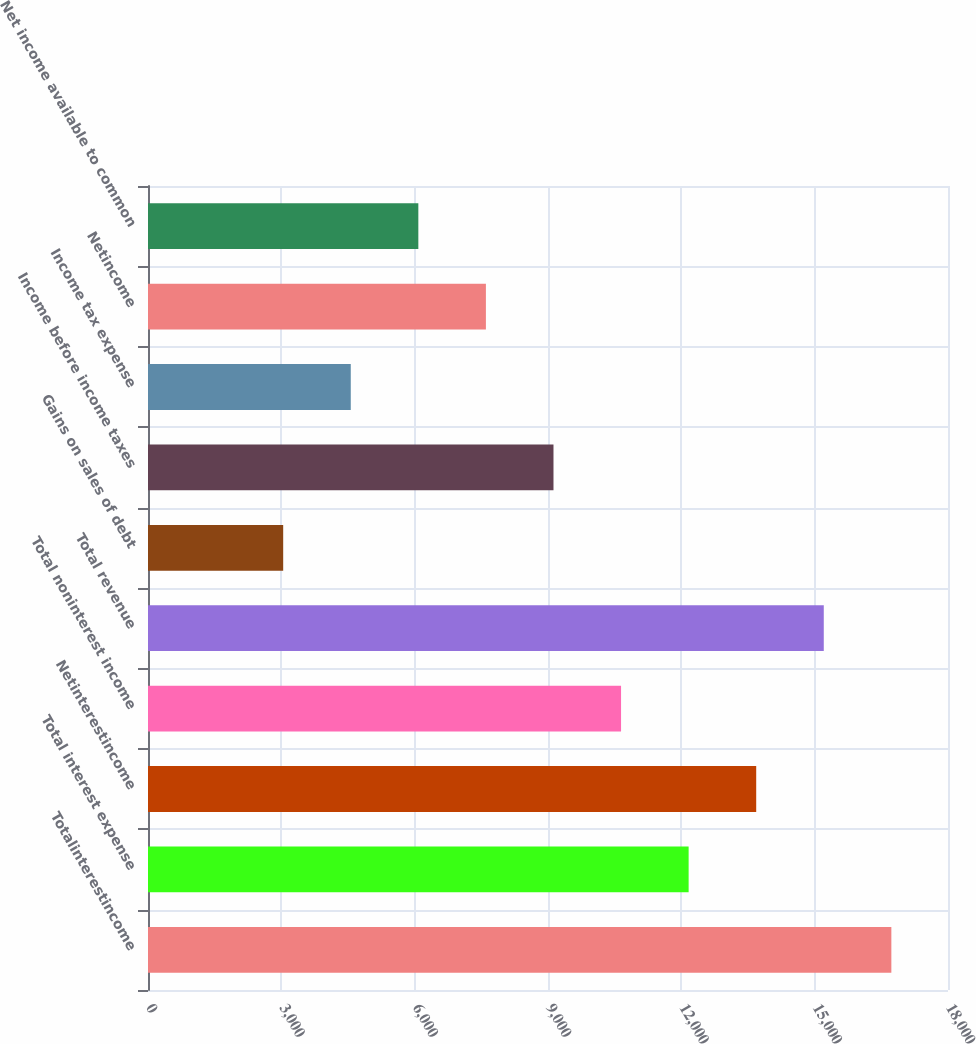Convert chart to OTSL. <chart><loc_0><loc_0><loc_500><loc_500><bar_chart><fcel>Totalinterestincome<fcel>Total interest expense<fcel>Netinterestincome<fcel>Total noninterest income<fcel>Total revenue<fcel>Gains on sales of debt<fcel>Income before income taxes<fcel>Income tax expense<fcel>Netincome<fcel>Net income available to common<nl><fcel>16725.4<fcel>12164.2<fcel>13684.6<fcel>10643.8<fcel>15205<fcel>3041.76<fcel>9123.38<fcel>4562.16<fcel>7602.97<fcel>6082.56<nl></chart> 